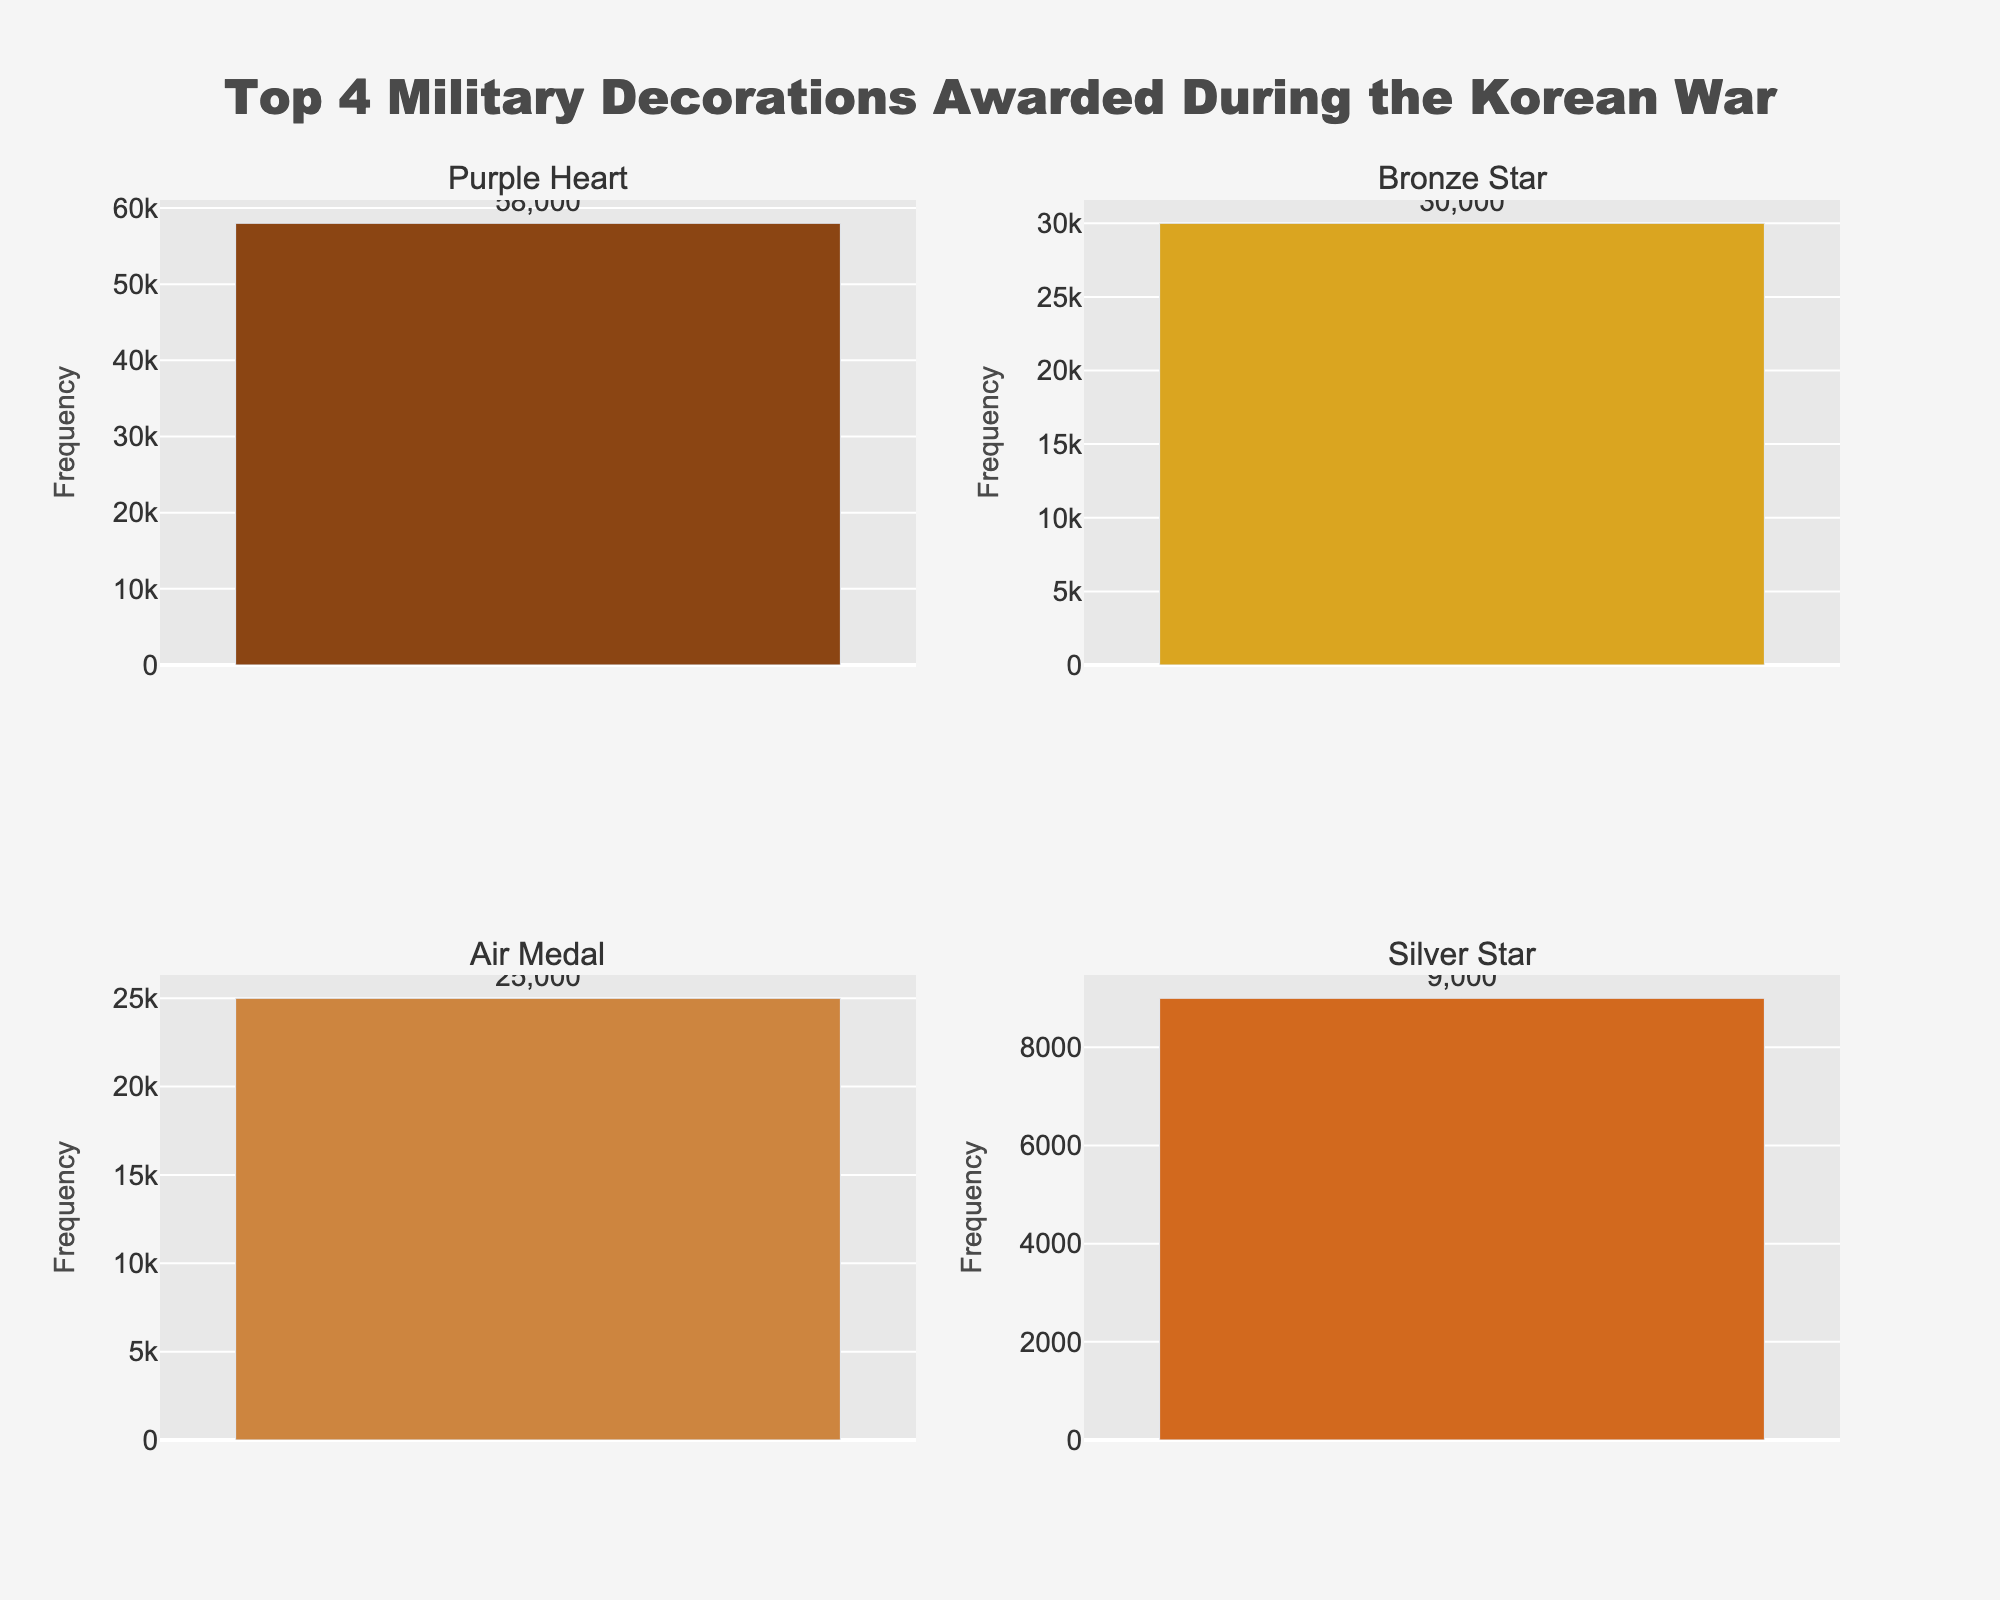Which medal has the highest frequency in the figure? The medal with the highest frequency is shown at the top left subplot with the longest bar. That is the Purple Heart with a frequency of 58,000.
Answer: Purple Heart What is the combined frequency of the Silver Star and Bronze Star medals? The frequencies for the Silver Star and Bronze Star are 9,000 and 30,000 respectively. Adding them together gives 9,000 + 30,000 = 39,000.
Answer: 39,000 Which has a higher frequency, the Air Medal or the Silver Star? Comparing the frequencies of the Air Medal (25,000) and the Silver Star (9,000), the Air Medal has a higher frequency.
Answer: Air Medal What is the average frequency of the top four medals? The frequencies of the top four medals are Purple Heart (58,000), Bronze Star (30,000), Air Medal (25,000), and Silver Star (9,000). Sum them up for a total of 122,000. The average is 122,000 / 4 = 30,500.
Answer: 30,500 Which medal depicted in the subplots has the lowest frequency? The four subplots display Purple Heart, Bronze Star, Air Medal, and Silver Star. Among these, the Silver Star has the lowest frequency with 9,000 awards.
Answer: Silver Star How do the frequencies of the Bronze Star and Air Medal compare? The Bronze Star has a frequency of 30,000, while the Air Medal has a frequency of 25,000. The Bronze Star is awarded more frequently.
Answer: Bronze Star What is the total frequency of the top 4 medals combined? The frequencies of the top four medals are Purple Heart (58,000), Bronze Star (30,000), Air Medal (25,000), and Silver Star (9,000). Adding them gives a total of 58,000 + 30,000 + 25,000 + 9,000 = 122,000.
Answer: 122,000 